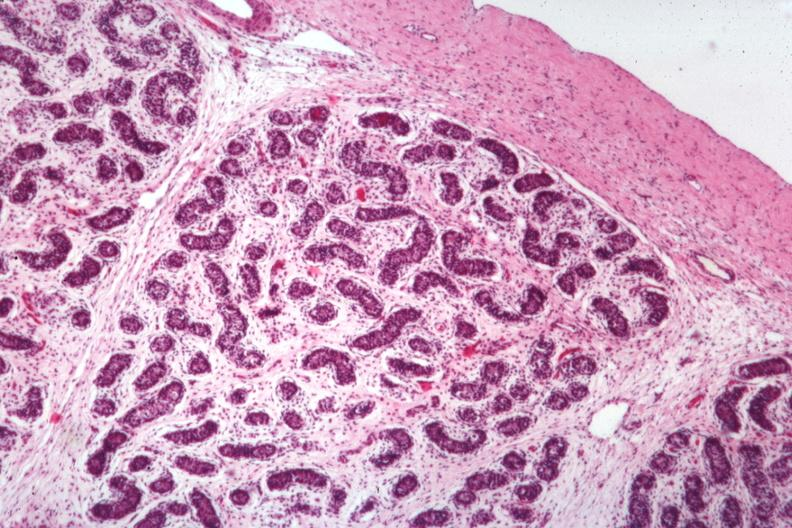what does this image show?
Answer the question using a single word or phrase. 7yo with craniopharyngioma and underdeveloped penis 